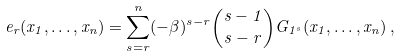Convert formula to latex. <formula><loc_0><loc_0><loc_500><loc_500>e _ { r } ( x _ { 1 } , \dots , x _ { n } ) = \sum _ { s = r } ^ { n } ( - \beta ) ^ { s - r } \binom { s - 1 } { s - r } G _ { 1 ^ { s } } ( x _ { 1 } , \dots , x _ { n } ) \, ,</formula> 